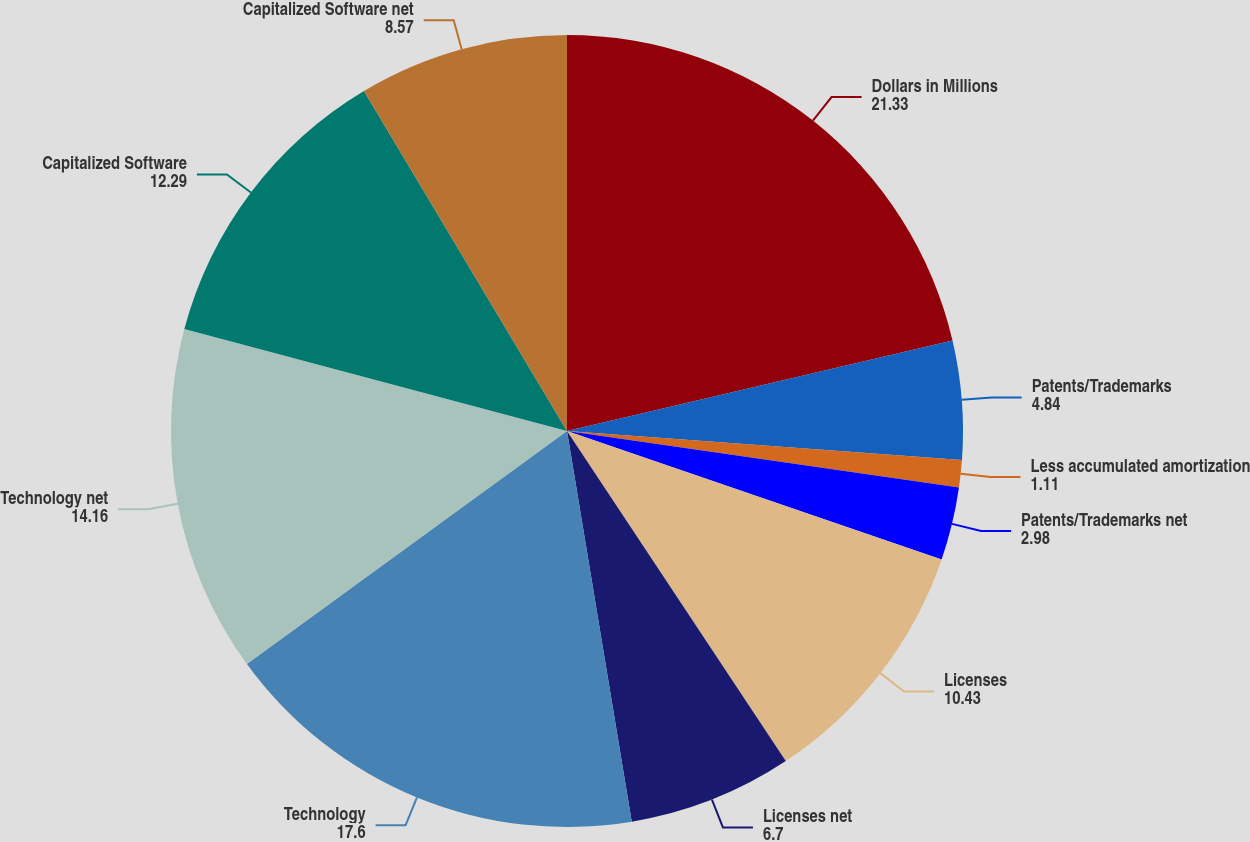Convert chart to OTSL. <chart><loc_0><loc_0><loc_500><loc_500><pie_chart><fcel>Dollars in Millions<fcel>Patents/Trademarks<fcel>Less accumulated amortization<fcel>Patents/Trademarks net<fcel>Licenses<fcel>Licenses net<fcel>Technology<fcel>Technology net<fcel>Capitalized Software<fcel>Capitalized Software net<nl><fcel>21.33%<fcel>4.84%<fcel>1.11%<fcel>2.98%<fcel>10.43%<fcel>6.7%<fcel>17.6%<fcel>14.16%<fcel>12.29%<fcel>8.57%<nl></chart> 